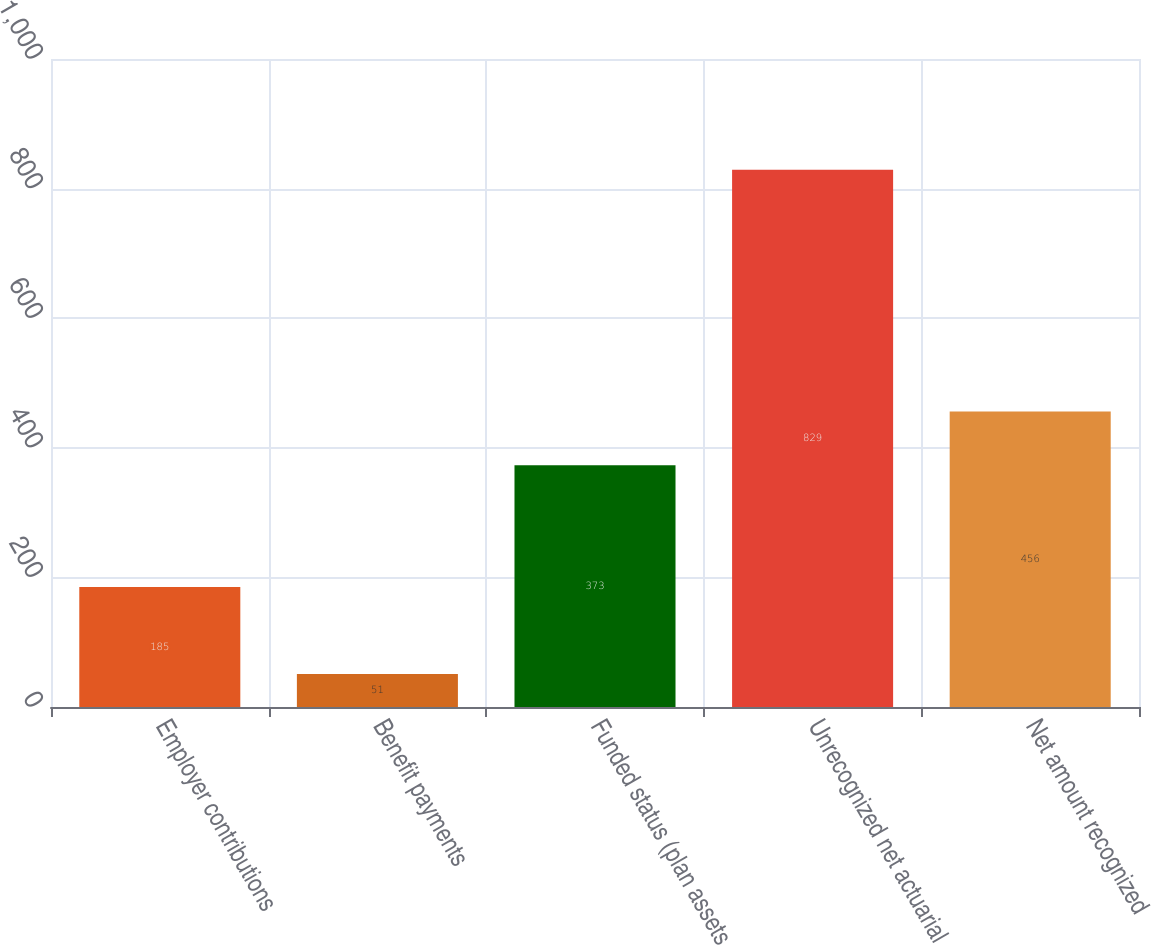Convert chart. <chart><loc_0><loc_0><loc_500><loc_500><bar_chart><fcel>Employer contributions<fcel>Benefit payments<fcel>Funded status (plan assets<fcel>Unrecognized net actuarial<fcel>Net amount recognized<nl><fcel>185<fcel>51<fcel>373<fcel>829<fcel>456<nl></chart> 